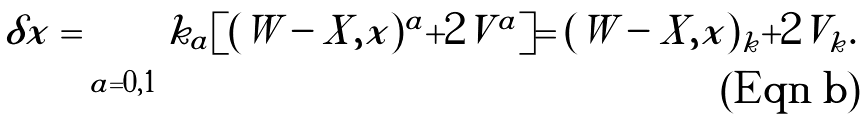<formula> <loc_0><loc_0><loc_500><loc_500>\delta x = \sum _ { a = 0 , 1 } k _ { a } [ ( W - X , x ) ^ { a } + 2 V ^ { a } ] = ( W - X , x ) _ { k } + 2 V _ { k } .</formula> 